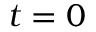<formula> <loc_0><loc_0><loc_500><loc_500>t = 0</formula> 